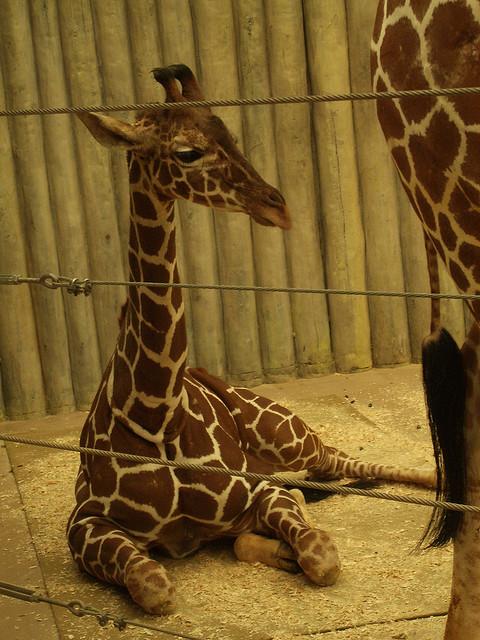Is this a young or old animal?
Concise answer only. Young. Is the area fenced?
Write a very short answer. Yes. Is this in a zoo?
Write a very short answer. Yes. 